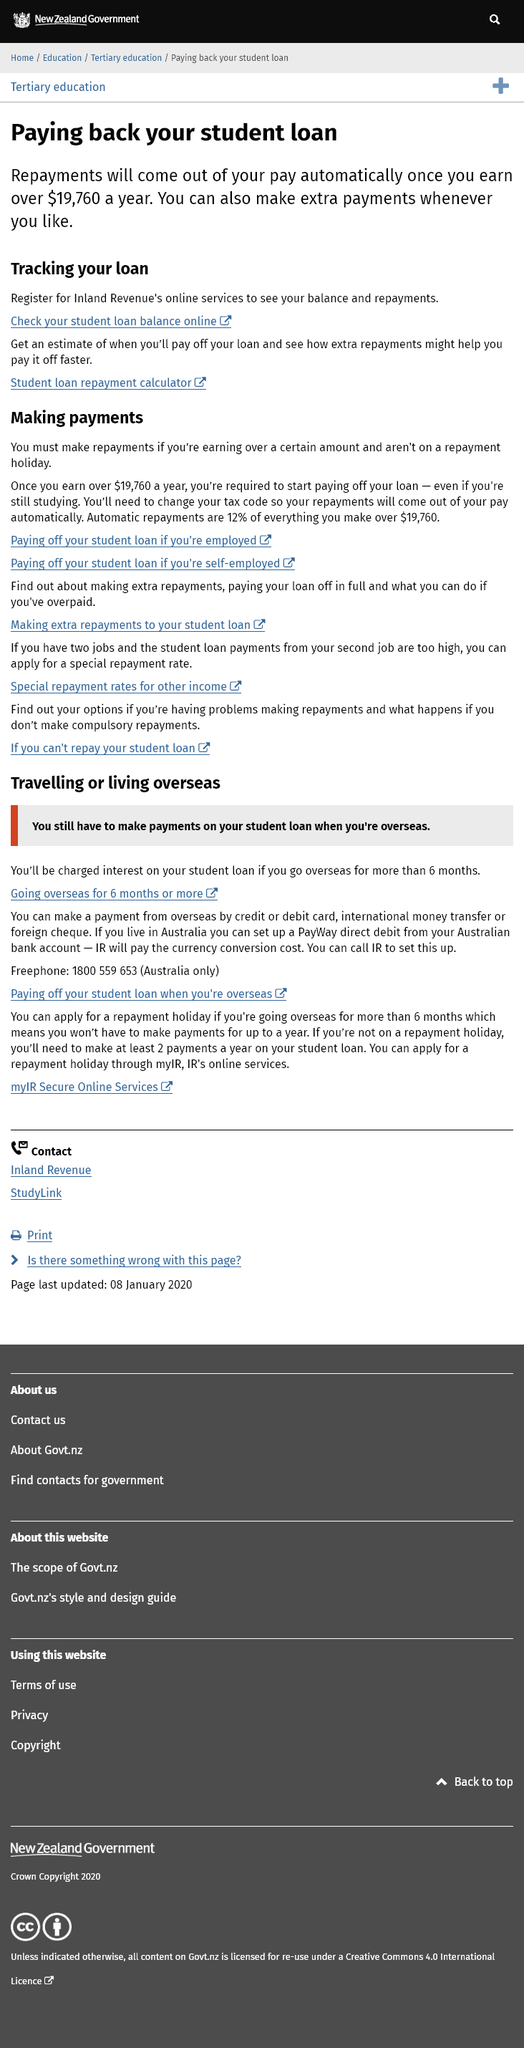Identify some key points in this picture. The automatic repayment amount is 12% of any income earned over $19,760. Automatic repayments for your student loan will be taken from your pay once you earn an annual income of $19,760 or more, as determined by the lender. You can view your student loan balance and repayments by registering for Inland Revenue's online services. 